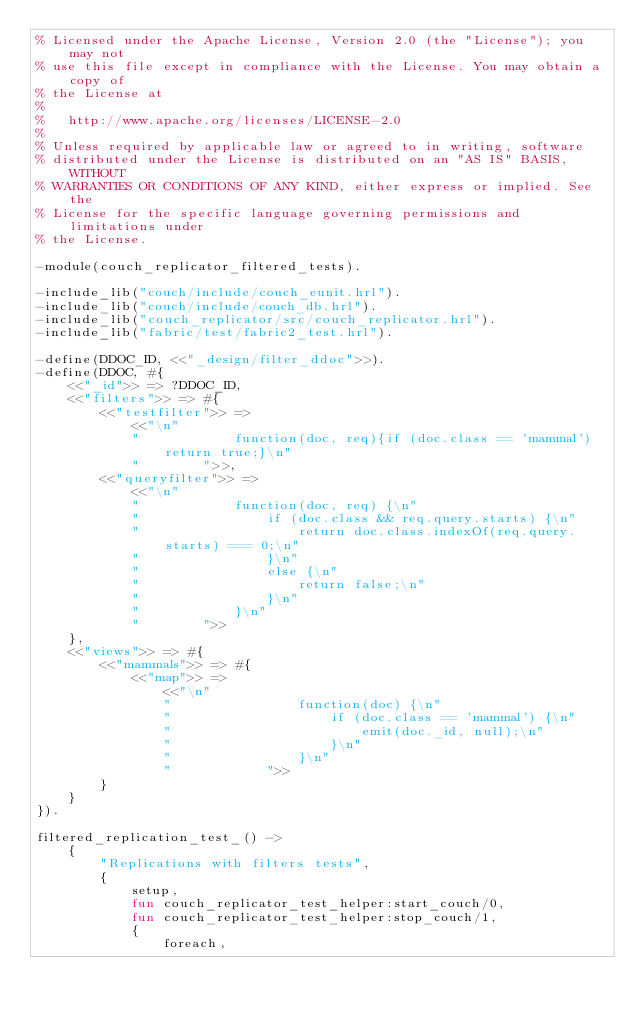<code> <loc_0><loc_0><loc_500><loc_500><_Erlang_>% Licensed under the Apache License, Version 2.0 (the "License"); you may not
% use this file except in compliance with the License. You may obtain a copy of
% the License at
%
%   http://www.apache.org/licenses/LICENSE-2.0
%
% Unless required by applicable law or agreed to in writing, software
% distributed under the License is distributed on an "AS IS" BASIS, WITHOUT
% WARRANTIES OR CONDITIONS OF ANY KIND, either express or implied. See the
% License for the specific language governing permissions and limitations under
% the License.

-module(couch_replicator_filtered_tests).

-include_lib("couch/include/couch_eunit.hrl").
-include_lib("couch/include/couch_db.hrl").
-include_lib("couch_replicator/src/couch_replicator.hrl").
-include_lib("fabric/test/fabric2_test.hrl").

-define(DDOC_ID, <<"_design/filter_ddoc">>).
-define(DDOC, #{
    <<"_id">> => ?DDOC_ID,
    <<"filters">> => #{
        <<"testfilter">> =>
            <<"\n"
            "            function(doc, req){if (doc.class == 'mammal') return true;}\n"
            "        ">>,
        <<"queryfilter">> =>
            <<"\n"
            "            function(doc, req) {\n"
            "                if (doc.class && req.query.starts) {\n"
            "                    return doc.class.indexOf(req.query.starts) === 0;\n"
            "                }\n"
            "                else {\n"
            "                    return false;\n"
            "                }\n"
            "            }\n"
            "        ">>
    },
    <<"views">> => #{
        <<"mammals">> => #{
            <<"map">> =>
                <<"\n"
                "                function(doc) {\n"
                "                    if (doc.class == 'mammal') {\n"
                "                        emit(doc._id, null);\n"
                "                    }\n"
                "                }\n"
                "            ">>
        }
    }
}).

filtered_replication_test_() ->
    {
        "Replications with filters tests",
        {
            setup,
            fun couch_replicator_test_helper:start_couch/0,
            fun couch_replicator_test_helper:stop_couch/1,
            {
                foreach,</code> 